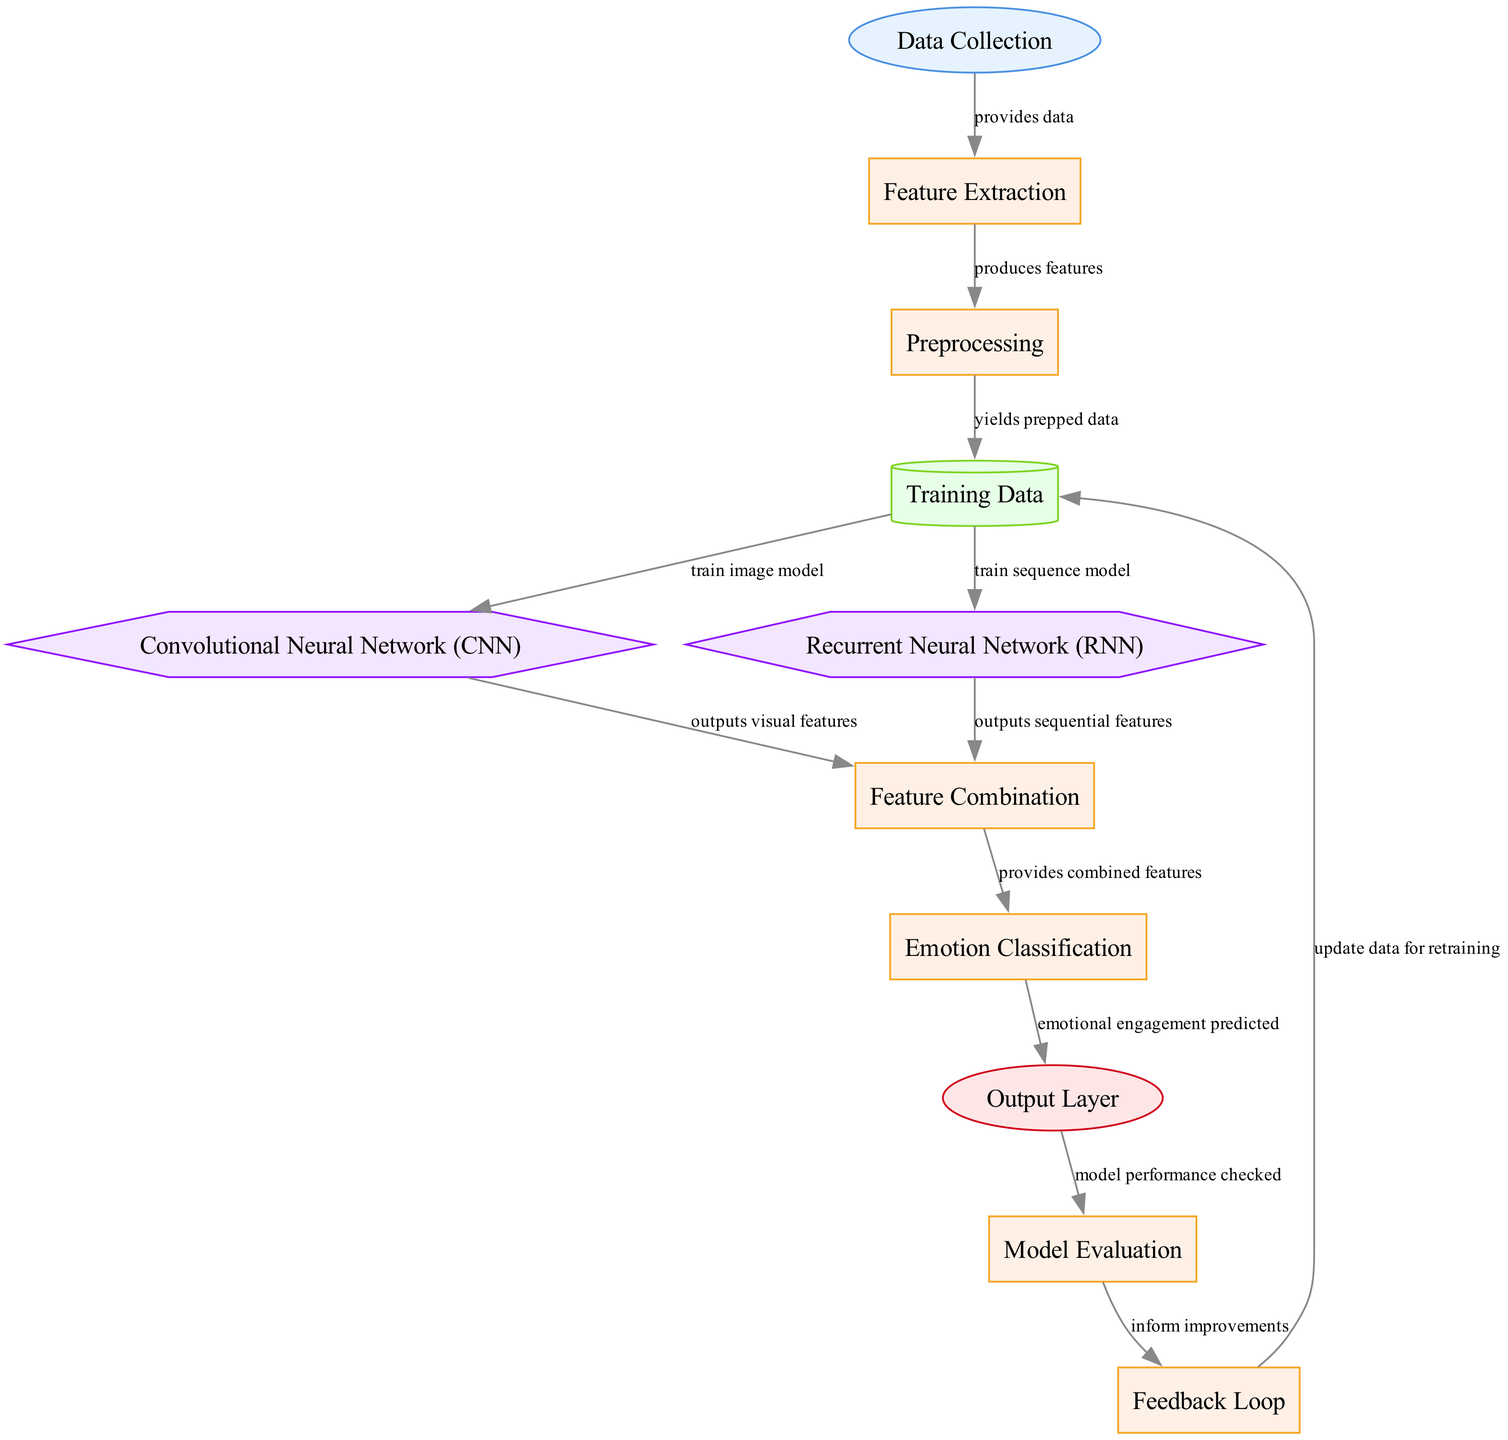What is the first node in the diagram? The first node in the diagram is labeled "Data Collection," which gathers data from educational gaming systems.
Answer: Data Collection How many process nodes are present in the diagram? The process nodes are "Feature Extraction," "Preprocessing," "Feature Combination," "Emotion Classification," "Model Evaluation," and "Feedback Loop," totaling six process nodes.
Answer: 6 What happens after the "Training Data"? After "Training Data," two models are trained: one for the "Convolutional Neural Network (CNN)" and another for the "Recurrent Neural Network (RNN)," both fed with the trained data.
Answer: Train image model and train sequence model Which nodes combine features? The "Feature Combination" node combines features outputted from both the "Convolutional Neural Network (CNN)" and the "Recurrent Neural Network (RNN)."
Answer: Feature Combination What is the output of the "Emotion Classification" process? The output from the "Emotion Classification" process is the predicted emotional engagement level, which is shown in the "Output Layer."
Answer: Predicted emotional engagement level Which node is responsible for model performance evaluation? The "Model Evaluation" node is responsible for checking the performance of the model using metrics such as accuracy and F1-score.
Answer: Model Evaluation What does the "Feedback Loop" provide for the "Training Data" node? The "Feedback Loop" informs improvements which in turn update the "Training Data" for retraining the models based on evaluation results.
Answer: Update data for retraining What type of model is the "Recurrent Neural Network"? The "Recurrent Neural Network" is classified as a model used to analyze sequential data such as click sequences and time series.
Answer: Recurrent Neural Network How many edges are there in the diagram? By counting the edges that connect the nodes, there are 12 edges in total, representing processes and flows between nodes.
Answer: 12 